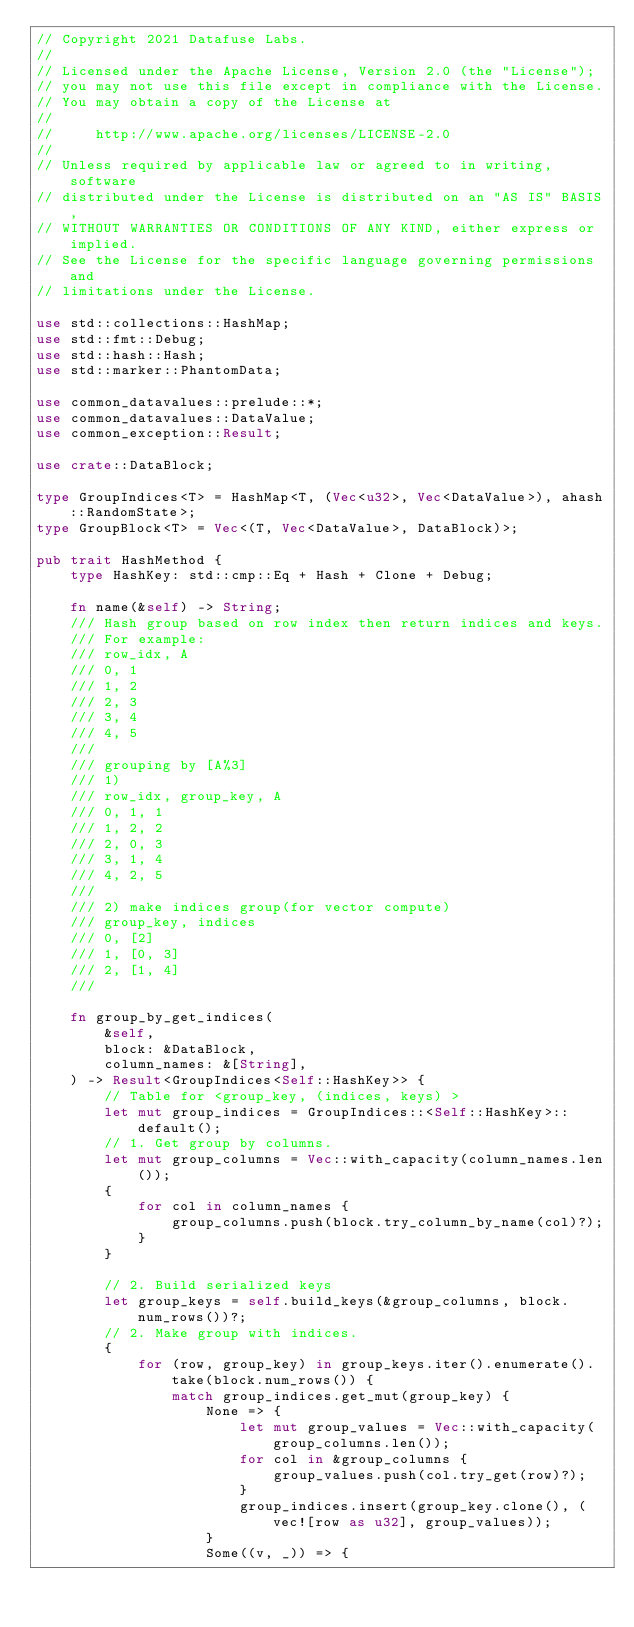Convert code to text. <code><loc_0><loc_0><loc_500><loc_500><_Rust_>// Copyright 2021 Datafuse Labs.
//
// Licensed under the Apache License, Version 2.0 (the "License");
// you may not use this file except in compliance with the License.
// You may obtain a copy of the License at
//
//     http://www.apache.org/licenses/LICENSE-2.0
//
// Unless required by applicable law or agreed to in writing, software
// distributed under the License is distributed on an "AS IS" BASIS,
// WITHOUT WARRANTIES OR CONDITIONS OF ANY KIND, either express or implied.
// See the License for the specific language governing permissions and
// limitations under the License.

use std::collections::HashMap;
use std::fmt::Debug;
use std::hash::Hash;
use std::marker::PhantomData;

use common_datavalues::prelude::*;
use common_datavalues::DataValue;
use common_exception::Result;

use crate::DataBlock;

type GroupIndices<T> = HashMap<T, (Vec<u32>, Vec<DataValue>), ahash::RandomState>;
type GroupBlock<T> = Vec<(T, Vec<DataValue>, DataBlock)>;

pub trait HashMethod {
    type HashKey: std::cmp::Eq + Hash + Clone + Debug;

    fn name(&self) -> String;
    /// Hash group based on row index then return indices and keys.
    /// For example:
    /// row_idx, A
    /// 0, 1
    /// 1, 2
    /// 2, 3
    /// 3, 4
    /// 4, 5
    ///
    /// grouping by [A%3]
    /// 1)
    /// row_idx, group_key, A
    /// 0, 1, 1
    /// 1, 2, 2
    /// 2, 0, 3
    /// 3, 1, 4
    /// 4, 2, 5
    ///
    /// 2) make indices group(for vector compute)
    /// group_key, indices
    /// 0, [2]
    /// 1, [0, 3]
    /// 2, [1, 4]
    ///

    fn group_by_get_indices(
        &self,
        block: &DataBlock,
        column_names: &[String],
    ) -> Result<GroupIndices<Self::HashKey>> {
        // Table for <group_key, (indices, keys) >
        let mut group_indices = GroupIndices::<Self::HashKey>::default();
        // 1. Get group by columns.
        let mut group_columns = Vec::with_capacity(column_names.len());
        {
            for col in column_names {
                group_columns.push(block.try_column_by_name(col)?);
            }
        }

        // 2. Build serialized keys
        let group_keys = self.build_keys(&group_columns, block.num_rows())?;
        // 2. Make group with indices.
        {
            for (row, group_key) in group_keys.iter().enumerate().take(block.num_rows()) {
                match group_indices.get_mut(group_key) {
                    None => {
                        let mut group_values = Vec::with_capacity(group_columns.len());
                        for col in &group_columns {
                            group_values.push(col.try_get(row)?);
                        }
                        group_indices.insert(group_key.clone(), (vec![row as u32], group_values));
                    }
                    Some((v, _)) => {</code> 